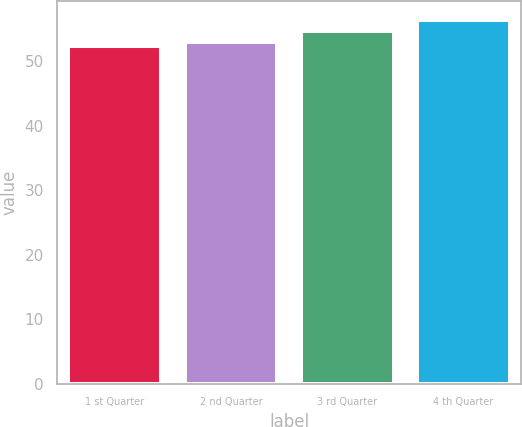<chart> <loc_0><loc_0><loc_500><loc_500><bar_chart><fcel>1 st Quarter<fcel>2 nd Quarter<fcel>3 rd Quarter<fcel>4 th Quarter<nl><fcel>52.23<fcel>52.87<fcel>54.58<fcel>56.4<nl></chart> 